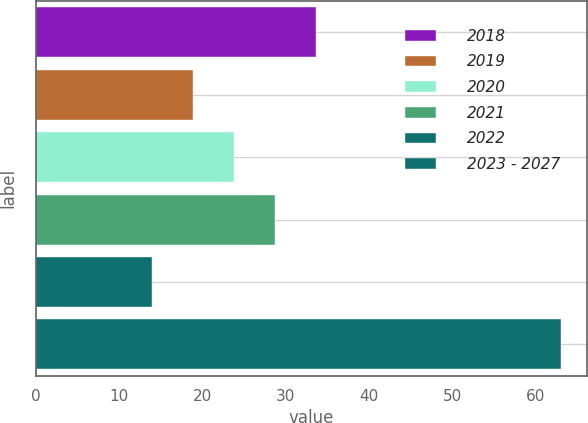Convert chart to OTSL. <chart><loc_0><loc_0><loc_500><loc_500><bar_chart><fcel>2018<fcel>2019<fcel>2020<fcel>2021<fcel>2022<fcel>2023 - 2027<nl><fcel>33.6<fcel>18.9<fcel>23.8<fcel>28.7<fcel>14<fcel>63<nl></chart> 